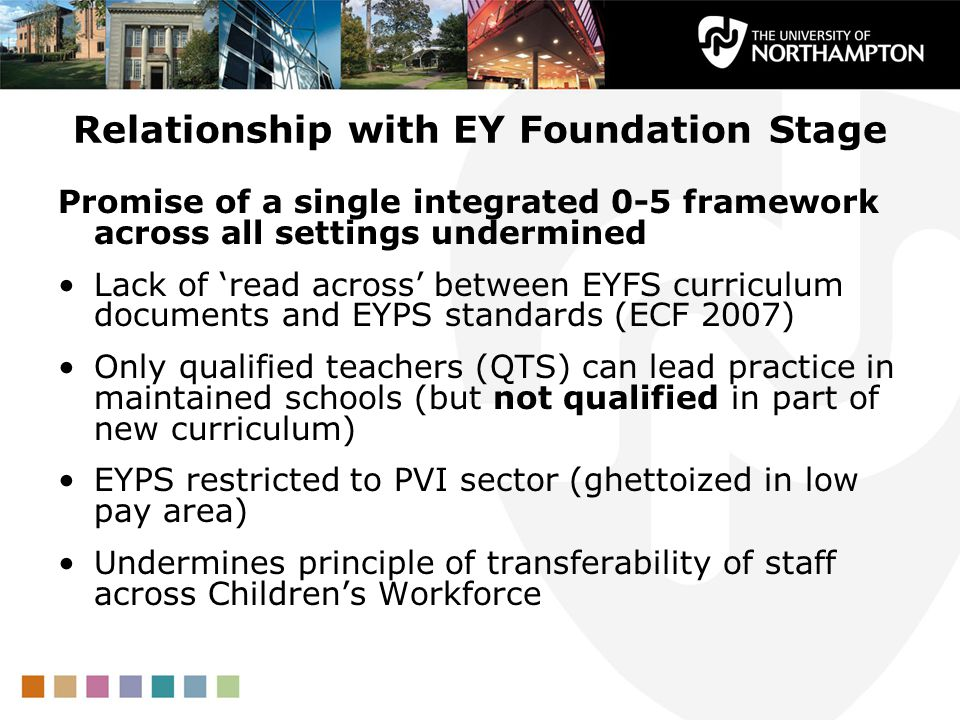What strategies could be implemented to address the issues of staff mobility and qualifications within the EYFS framework? To address the issues of staff mobility and qualifications within the EYFS framework, several strategies could be proposed. Firstly, aligning the EYFS curriculum documents with the EYPS standards could provide a more cohesive and clear guideline for educators, ensuring consistency across different settings. Providing incentives for further qualifications and professional development can help in upskilling the workforce, making them more versatile and better equipped to deliver high-quality education. Additionally, efforts to improve pay and conditions in the PVI sector could help retain skilled professionals and allow for better mobility. Establishing more integrated pathways for career progression within the field could encourage educators to stay within the profession, thereby enhancing the overall quality of the workforce. 